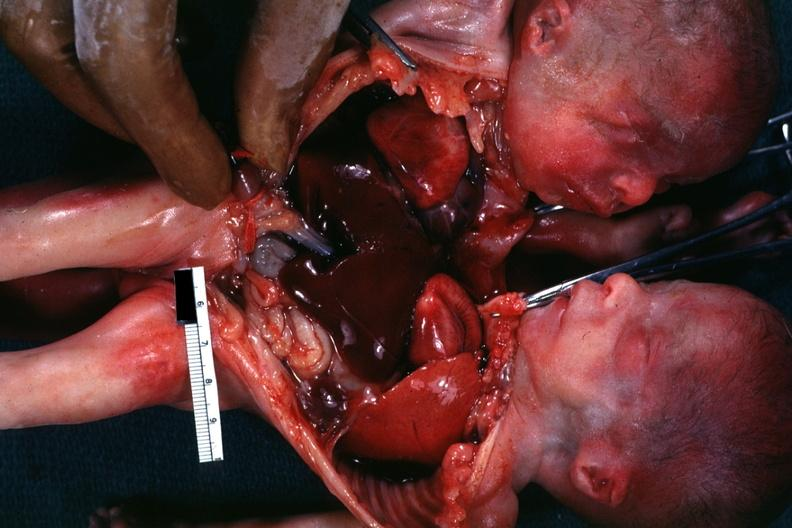does this image show joined anterior chest and abdomen?
Answer the question using a single word or phrase. Yes 